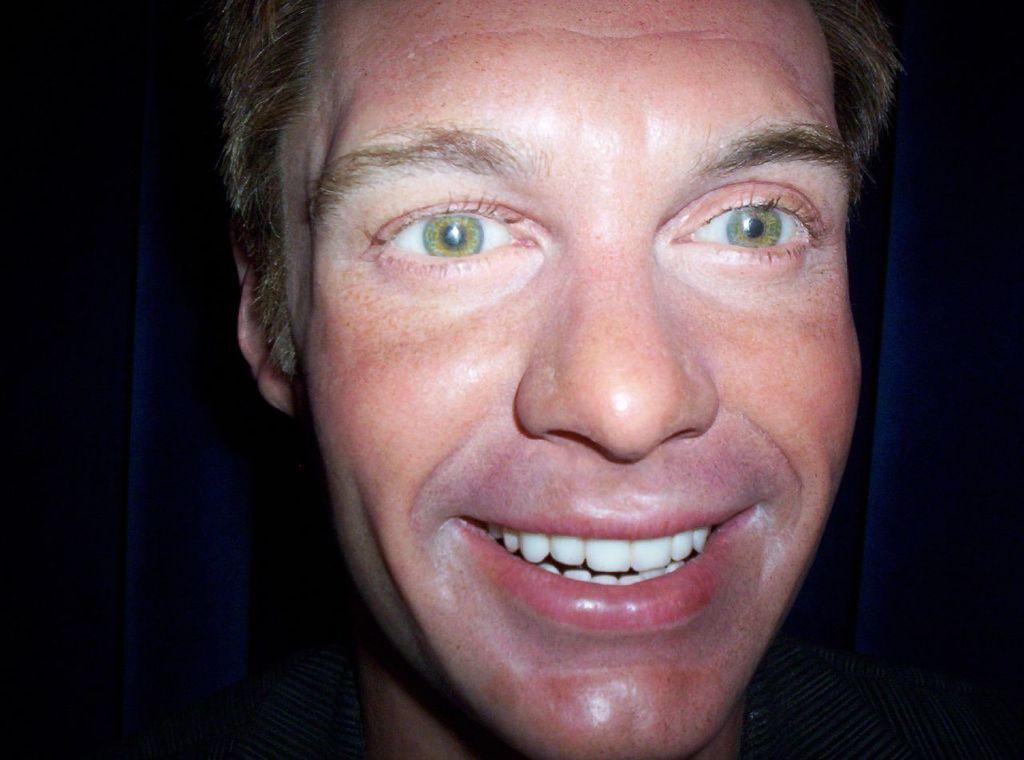Describe this image in one or two sentences. In this image, we can see a person face on the dark background. 